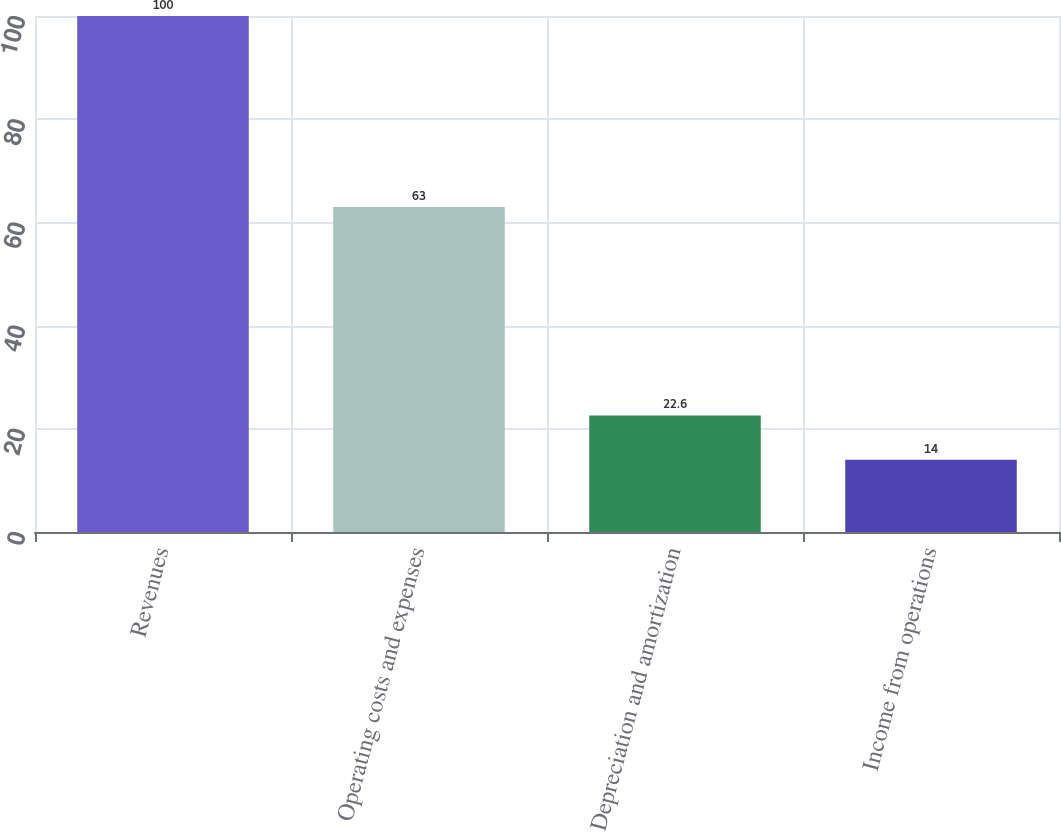Convert chart. <chart><loc_0><loc_0><loc_500><loc_500><bar_chart><fcel>Revenues<fcel>Operating costs and expenses<fcel>Depreciation and amortization<fcel>Income from operations<nl><fcel>100<fcel>63<fcel>22.6<fcel>14<nl></chart> 